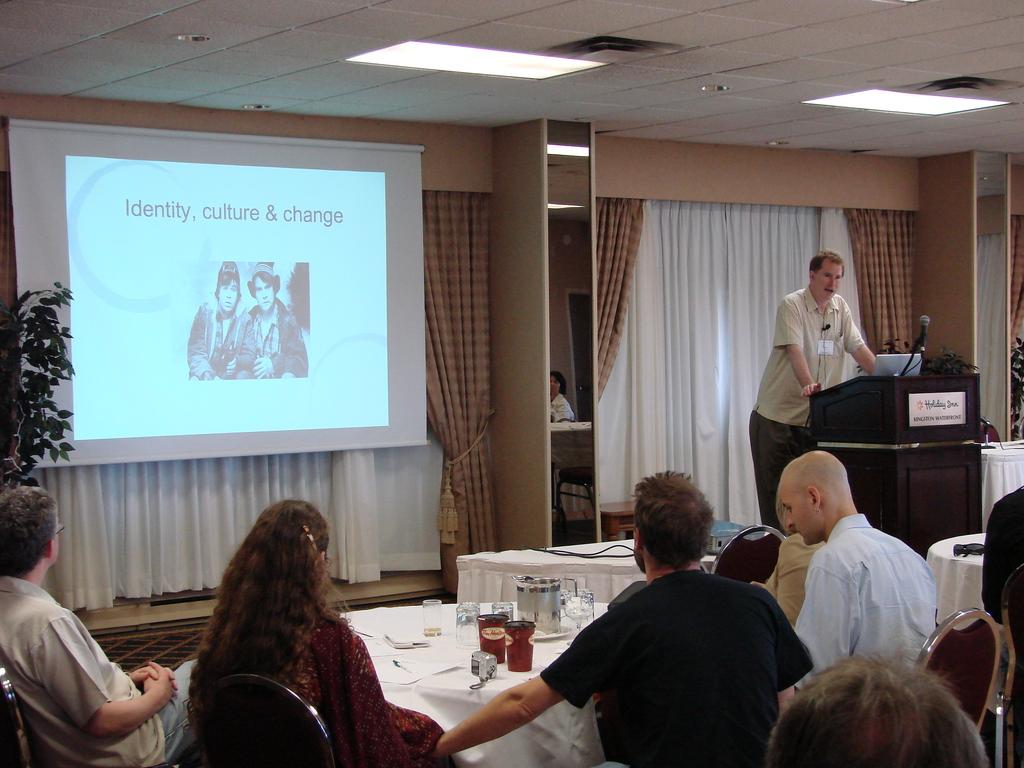What is the topic covered in this lecture?
Offer a terse response. Identity, culture & change. What inn is cited on the podium?
Offer a very short reply. Holiday inn. 